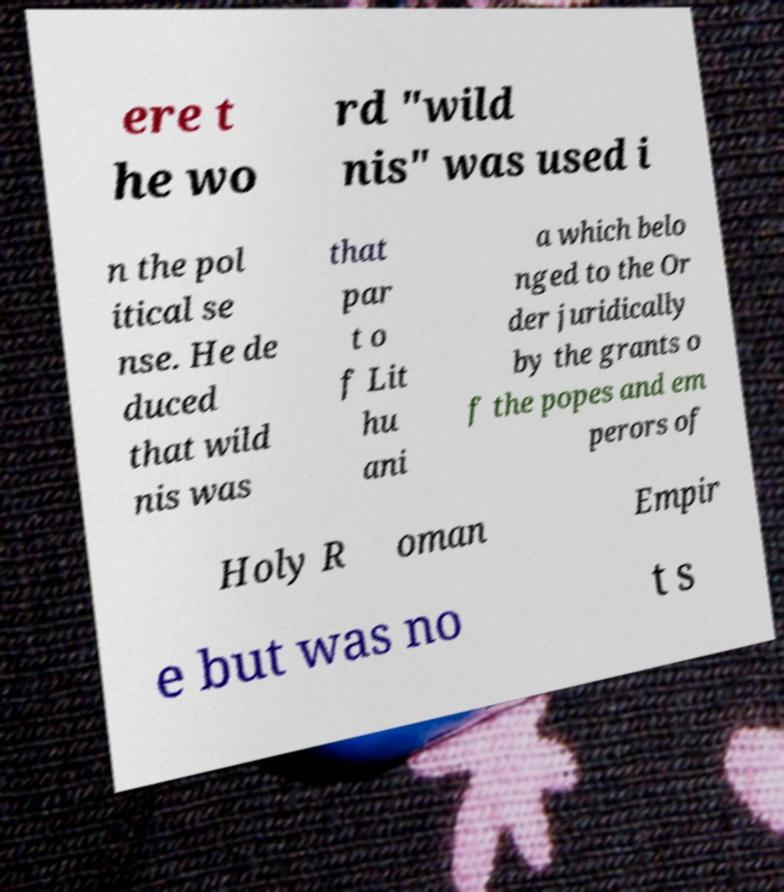Could you assist in decoding the text presented in this image and type it out clearly? ere t he wo rd "wild nis" was used i n the pol itical se nse. He de duced that wild nis was that par t o f Lit hu ani a which belo nged to the Or der juridically by the grants o f the popes and em perors of Holy R oman Empir e but was no t s 